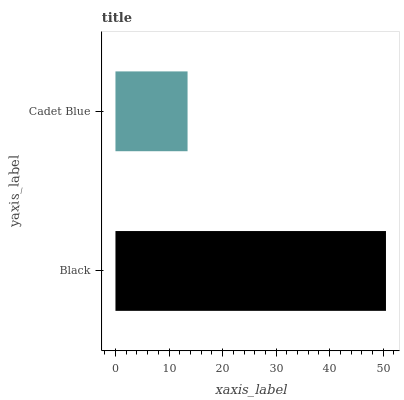Is Cadet Blue the minimum?
Answer yes or no. Yes. Is Black the maximum?
Answer yes or no. Yes. Is Cadet Blue the maximum?
Answer yes or no. No. Is Black greater than Cadet Blue?
Answer yes or no. Yes. Is Cadet Blue less than Black?
Answer yes or no. Yes. Is Cadet Blue greater than Black?
Answer yes or no. No. Is Black less than Cadet Blue?
Answer yes or no. No. Is Black the high median?
Answer yes or no. Yes. Is Cadet Blue the low median?
Answer yes or no. Yes. Is Cadet Blue the high median?
Answer yes or no. No. Is Black the low median?
Answer yes or no. No. 